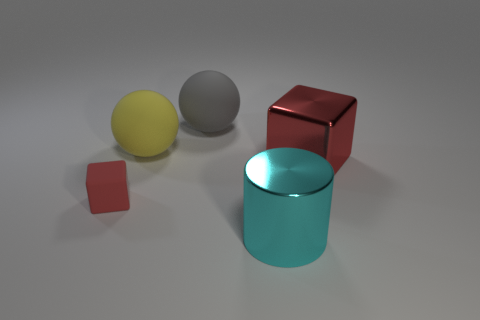Do the tiny matte object and the big metallic cube have the same color?
Your answer should be very brief. Yes. Is the number of yellow rubber things in front of the large cyan metallic object less than the number of cyan shiny objects behind the gray ball?
Keep it short and to the point. No. Are there any other things that are the same shape as the yellow rubber thing?
Keep it short and to the point. Yes. The other object that is the same shape as the gray rubber thing is what color?
Your answer should be compact. Yellow. Do the big cyan metal thing and the metal object that is behind the small matte object have the same shape?
Ensure brevity in your answer.  No. How many things are either cubes that are right of the large metal cylinder or large cyan cylinders right of the red matte thing?
Your response must be concise. 2. What is the material of the tiny thing?
Your response must be concise. Rubber. What number of other objects are there of the same size as the shiny cylinder?
Provide a short and direct response. 3. There is a red thing that is on the right side of the red matte object; what is its size?
Offer a terse response. Large. What material is the red object behind the red thing on the left side of the large object in front of the big red shiny object?
Your response must be concise. Metal. 